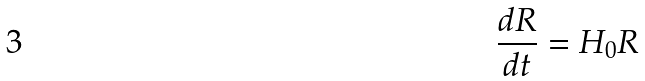<formula> <loc_0><loc_0><loc_500><loc_500>\frac { d R } { d t } = H _ { 0 } R</formula> 